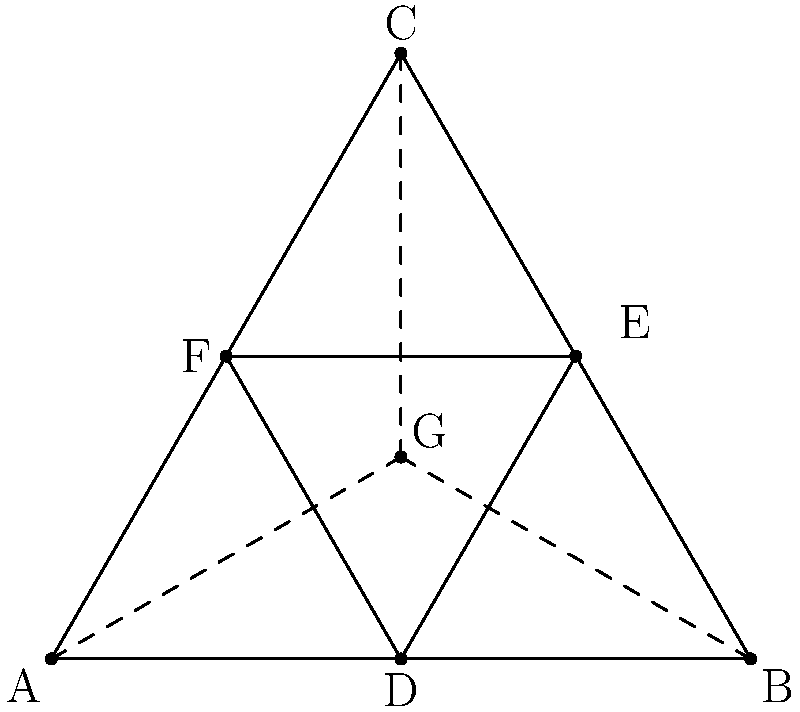In Islamic geometric art, the hexagram is a common motif symbolizing the harmony between heaven and earth. Consider the equilateral triangle ABC with its inscribed triangle DEF formed by connecting the midpoints of the sides. If G is the centroid of triangle DEF, what is the ratio of the area of triangle DEF to the area of triangle ABC? How might this ratio reflect the Islamic concept of divine order in the universe? Let's approach this step-by-step:

1) First, recall that the midpoint theorem states that a line segment joining the midpoints of two sides of a triangle is parallel to the third side and half the length.

2) This means that triangle DEF is similar to triangle ABC, with each side of DEF being half the length of the corresponding side of ABC.

3) The ratio of the areas of similar triangles is equal to the square of the ratio of their corresponding sides. So:

   $$\frac{\text{Area of DEF}}{\text{Area of ABC}} = (\frac{1}{2})^2 = \frac{1}{4}$$

4) Therefore, the area of triangle DEF is exactly 1/4 of the area of triangle ABC.

5) In Islamic geometry, this 1:4 ratio could be interpreted as representing the relationship between the manifest (physical) world and the divine realm. The smaller triangle (DEF) nested within the larger one (ABC) might symbolize how the earthly realm is a reflection of the cosmic order, but on a smaller scale.

6) The centroid G, being the point where the medians intersect, could represent the balance and unity in Islamic cosmology. It divides each median in a 2:1 ratio, which could be seen as another manifestation of divine proportion.

7) The fact that this geometric relationship is constant and unchanging, regardless of the size of the original triangle, could be viewed as a reflection of the immutable laws of the universe in Islamic thought.
Answer: 1:4 